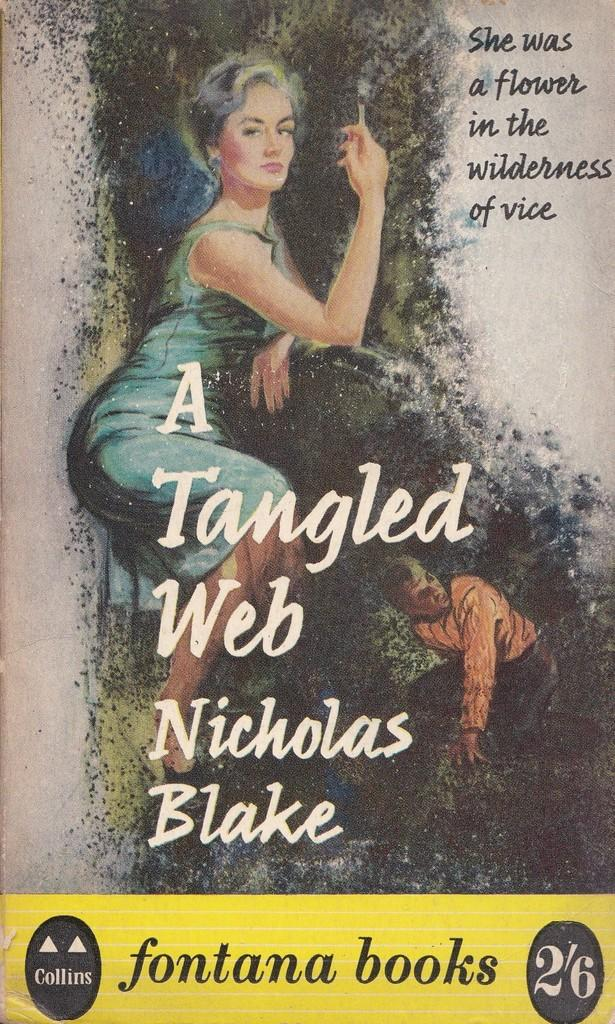<image>
Provide a brief description of the given image. a book called A Tangled Web by Nicholas Blake 